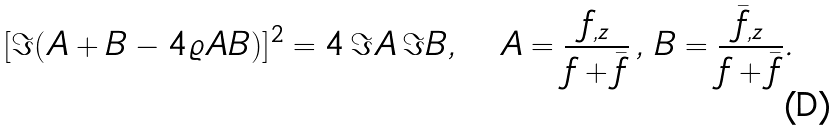<formula> <loc_0><loc_0><loc_500><loc_500>[ \Im ( A + B - 4 \varrho A B ) ] ^ { 2 } = 4 \, \Im A \, \Im B , \quad A = \frac { f _ { , z } } { f + \bar { f } } \, , \, B = \frac { \bar { f } _ { , z } } { f + \bar { f } } .</formula> 